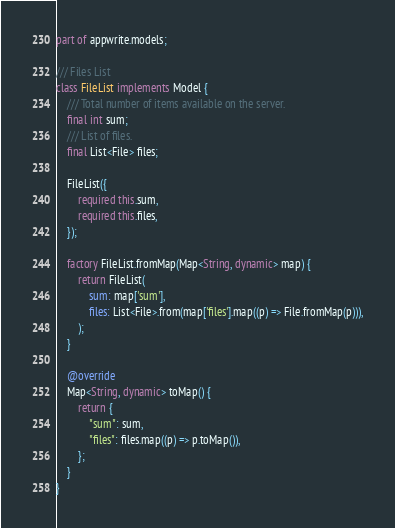<code> <loc_0><loc_0><loc_500><loc_500><_Dart_>part of appwrite.models;

/// Files List
class FileList implements Model {
    /// Total number of items available on the server.
    final int sum;
    /// List of files.
    final List<File> files;

    FileList({
        required this.sum,
        required this.files,
    });

    factory FileList.fromMap(Map<String, dynamic> map) {
        return FileList(
            sum: map['sum'],
            files: List<File>.from(map['files'].map((p) => File.fromMap(p))),
        );
    }

    @override
    Map<String, dynamic> toMap() {
        return {
            "sum": sum,
            "files": files.map((p) => p.toMap()),
        };
    }
}
</code> 